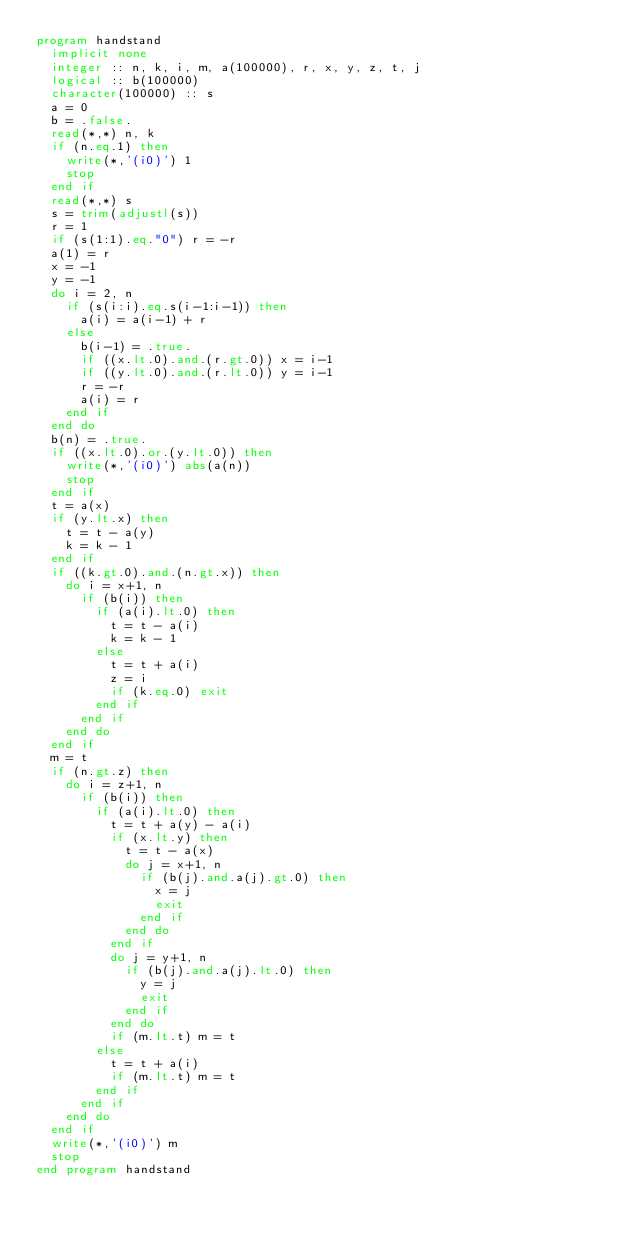<code> <loc_0><loc_0><loc_500><loc_500><_FORTRAN_>program handstand
  implicit none
  integer :: n, k, i, m, a(100000), r, x, y, z, t, j
  logical :: b(100000)
  character(100000) :: s
  a = 0
  b = .false.
  read(*,*) n, k
  if (n.eq.1) then
    write(*,'(i0)') 1
    stop
  end if
  read(*,*) s
  s = trim(adjustl(s))
  r = 1
  if (s(1:1).eq."0") r = -r
  a(1) = r
  x = -1
  y = -1
  do i = 2, n
    if (s(i:i).eq.s(i-1:i-1)) then
      a(i) = a(i-1) + r
    else
      b(i-1) = .true.
      if ((x.lt.0).and.(r.gt.0)) x = i-1
      if ((y.lt.0).and.(r.lt.0)) y = i-1
      r = -r
      a(i) = r
    end if
  end do
  b(n) = .true.
  if ((x.lt.0).or.(y.lt.0)) then
    write(*,'(i0)') abs(a(n))
    stop
  end if
  t = a(x)
  if (y.lt.x) then
    t = t - a(y)
    k = k - 1
  end if
  if ((k.gt.0).and.(n.gt.x)) then
    do i = x+1, n
      if (b(i)) then
        if (a(i).lt.0) then
          t = t - a(i)
          k = k - 1
        else
          t = t + a(i)
          z = i
          if (k.eq.0) exit
        end if
      end if
    end do
  end if
  m = t
  if (n.gt.z) then
    do i = z+1, n
      if (b(i)) then
        if (a(i).lt.0) then
          t = t + a(y) - a(i)
          if (x.lt.y) then
            t = t - a(x)
            do j = x+1, n
              if (b(j).and.a(j).gt.0) then
                x = j
                exit
              end if
            end do
          end if
          do j = y+1, n
            if (b(j).and.a(j).lt.0) then
              y = j
              exit
            end if
          end do
          if (m.lt.t) m = t
        else
          t = t + a(i)
          if (m.lt.t) m = t
        end if
      end if
    end do
  end if
  write(*,'(i0)') m
  stop
end program handstand</code> 